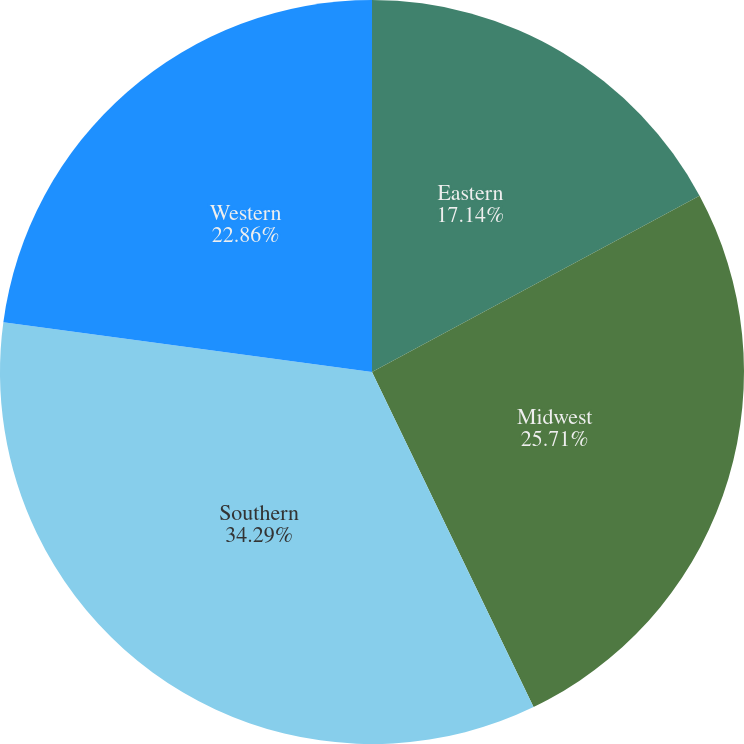Convert chart to OTSL. <chart><loc_0><loc_0><loc_500><loc_500><pie_chart><fcel>Eastern<fcel>Midwest<fcel>Southern<fcel>Western<nl><fcel>17.14%<fcel>25.71%<fcel>34.29%<fcel>22.86%<nl></chart> 